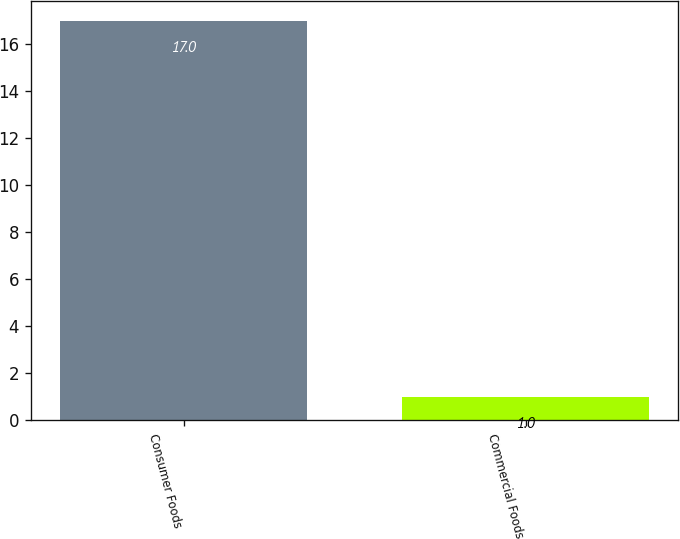<chart> <loc_0><loc_0><loc_500><loc_500><bar_chart><fcel>Consumer Foods<fcel>Commercial Foods<nl><fcel>17<fcel>1<nl></chart> 